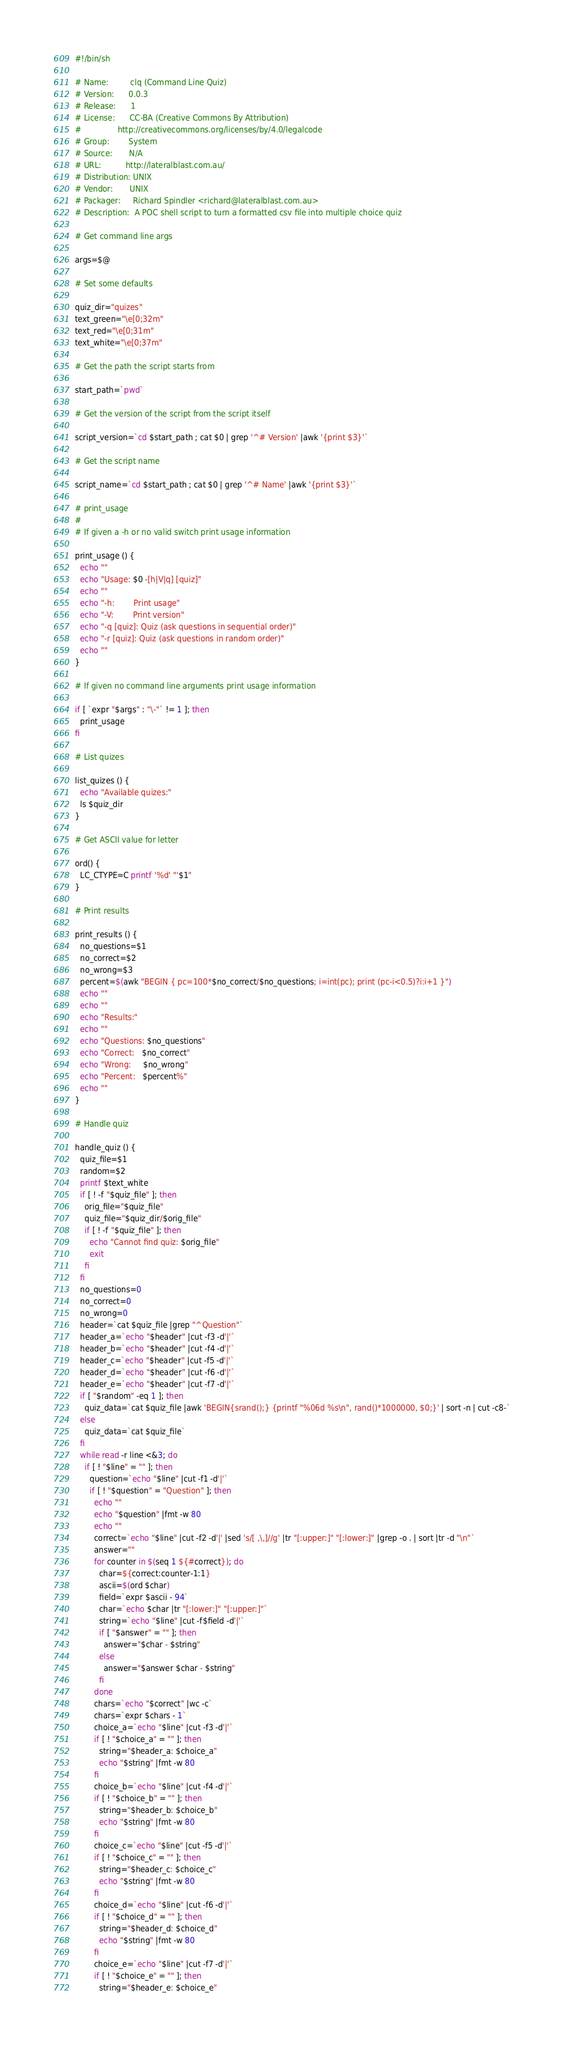Convert code to text. <code><loc_0><loc_0><loc_500><loc_500><_Bash_>#!/bin/sh

# Name:         clq (Command Line Quiz)
# Version:      0.0.3
# Release:      1
# License:      CC-BA (Creative Commons By Attribution)
#               http://creativecommons.org/licenses/by/4.0/legalcode
# Group:        System
# Source:       N/A
# URL:          http://lateralblast.com.au/
# Distribution: UNIX
# Vendor:       UNIX
# Packager:     Richard Spindler <richard@lateralblast.com.au>
# Description:  A POC shell script to turn a formatted csv file into multiple choice quiz

# Get command line args

args=$@

# Set some defaults

quiz_dir="quizes"
text_green="\e[0;32m"
text_red="\e[0;31m"
text_white="\e[0;37m"

# Get the path the script starts from

start_path=`pwd`

# Get the version of the script from the script itself

script_version=`cd $start_path ; cat $0 | grep '^# Version' |awk '{print $3}'`

# Get the script name

script_name=`cd $start_path ; cat $0 | grep '^# Name' |awk '{print $3}'`

# print_usage
#
# If given a -h or no valid switch print usage information

print_usage () {
  echo ""
  echo "Usage: $0 -[h|V|q] [quiz]"
  echo ""
  echo "-h:        Print usage"
  echo "-V:        Print version"
  echo "-q [quiz]: Quiz (ask questions in sequential order)"
  echo "-r [quiz]: Quiz (ask questions in random order)"
  echo ""
}

# If given no command line arguments print usage information

if [ `expr "$args" : "\-"` != 1 ]; then
  print_usage
fi

# List quizes

list_quizes () {
  echo "Available quizes:"
  ls $quiz_dir
}

# Get ASCII value for letter

ord() {
  LC_CTYPE=C printf '%d' "'$1"
}

# Print results

print_results () {
  no_questions=$1
  no_correct=$2
  no_wrong=$3
  percent=$(awk "BEGIN { pc=100*$no_correct/$no_questions; i=int(pc); print (pc-i<0.5)?i:i+1 }")
  echo ""
  echo ""
  echo "Results:"
  echo ""
  echo "Questions: $no_questions"
  echo "Correct:   $no_correct"
  echo "Wrong:     $no_wrong"
  echo "Percent:   $percent%"
  echo ""
}

# Handle quiz

handle_quiz () {
  quiz_file=$1
  random=$2
  printf $text_white
  if [ ! -f "$quiz_file" ]; then
    orig_file="$quiz_file"
    quiz_file="$quiz_dir/$orig_file"
    if [ ! -f "$quiz_file" ]; then
      echo "Cannot find quiz: $orig_file"
      exit
    fi
  fi 
  no_questions=0
  no_correct=0
  no_wrong=0
  header=`cat $quiz_file |grep "^Question"`
  header_a=`echo "$header" |cut -f3 -d'|'`
  header_b=`echo "$header" |cut -f4 -d'|'`
  header_c=`echo "$header" |cut -f5 -d'|'`
  header_d=`echo "$header" |cut -f6 -d'|'`
  header_e=`echo "$header" |cut -f7 -d'|'`
  if [ "$random" -eq 1 ]; then
    quiz_data=`cat $quiz_file |awk 'BEGIN{srand();} {printf "%06d %s\n", rand()*1000000, $0;}' | sort -n | cut -c8-`
  else
    quiz_data=`cat $quiz_file`
  fi
  while read -r line <&3; do
    if [ ! "$line" = "" ]; then
      question=`echo "$line" |cut -f1 -d'|'`
      if [ ! "$question" = "Question" ]; then
        echo ""
        echo "$question" |fmt -w 80
        echo ""
        correct=`echo "$line" |cut -f2 -d'|' |sed 's/[ ,\,]//g' |tr "[:upper:]" "[:lower:]" |grep -o . | sort |tr -d "\n"`
        answer=""
        for counter in $(seq 1 ${#correct}); do
          char=${correct:counter-1:1}
          ascii=$(ord $char)
          field=`expr $ascii - 94`
          char=`echo $char |tr "[:lower:]" "[:upper:]"`
          string=`echo "$line" |cut -f$field -d'|'`
          if [ "$answer" = "" ]; then
            answer="$char - $string"
          else
            answer="$answer $char - $string"
          fi
        done
        chars=`echo "$correct" |wc -c`
        chars=`expr $chars - 1`
        choice_a=`echo "$line" |cut -f3 -d'|'`
        if [ ! "$choice_a" = "" ]; then
          string="$header_a: $choice_a"
          echo "$string" |fmt -w 80
        fi
        choice_b=`echo "$line" |cut -f4 -d'|'`
        if [ ! "$choice_b" = "" ]; then
          string="$header_b: $choice_b"
          echo "$string" |fmt -w 80
        fi
        choice_c=`echo "$line" |cut -f5 -d'|'`
        if [ ! "$choice_c" = "" ]; then
          string="$header_c: $choice_c"
          echo "$string" |fmt -w 80
        fi
        choice_d=`echo "$line" |cut -f6 -d'|'`
        if [ ! "$choice_d" = "" ]; then
          string="$header_d: $choice_d"
          echo "$string" |fmt -w 80
        fi
        choice_e=`echo "$line" |cut -f7 -d'|'`
        if [ ! "$choice_e" = "" ]; then
          string="$header_e: $choice_e"</code> 